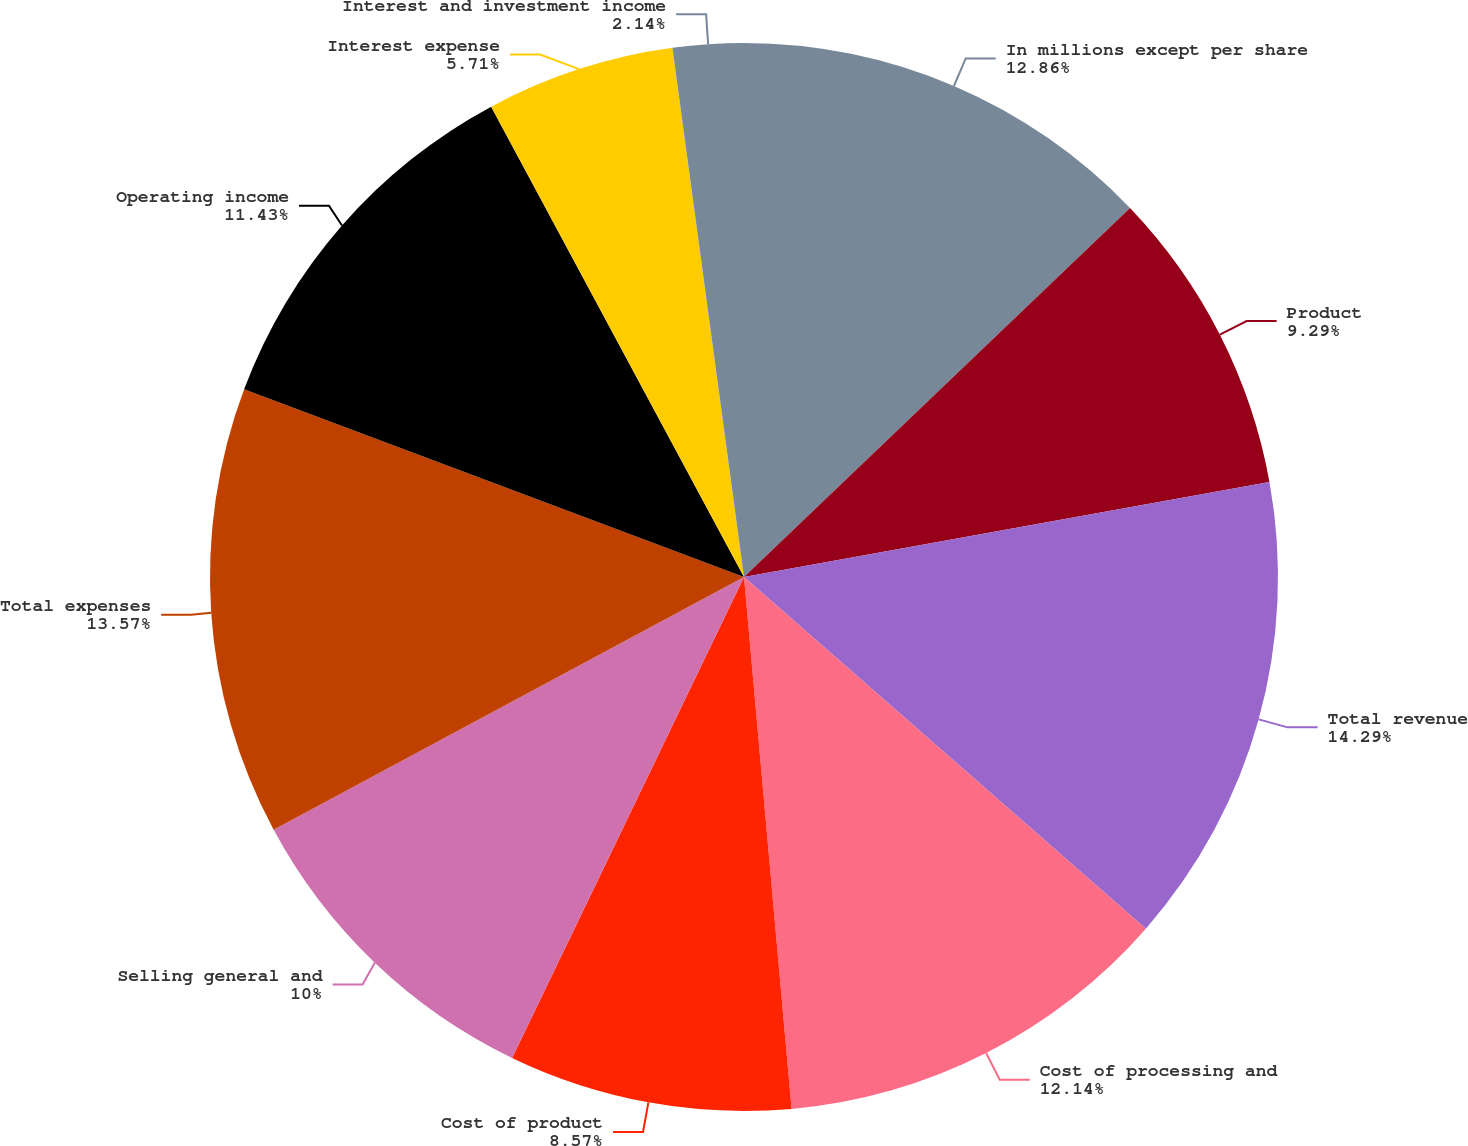Convert chart to OTSL. <chart><loc_0><loc_0><loc_500><loc_500><pie_chart><fcel>In millions except per share<fcel>Product<fcel>Total revenue<fcel>Cost of processing and<fcel>Cost of product<fcel>Selling general and<fcel>Total expenses<fcel>Operating income<fcel>Interest expense<fcel>Interest and investment income<nl><fcel>12.86%<fcel>9.29%<fcel>14.29%<fcel>12.14%<fcel>8.57%<fcel>10.0%<fcel>13.57%<fcel>11.43%<fcel>5.71%<fcel>2.14%<nl></chart> 